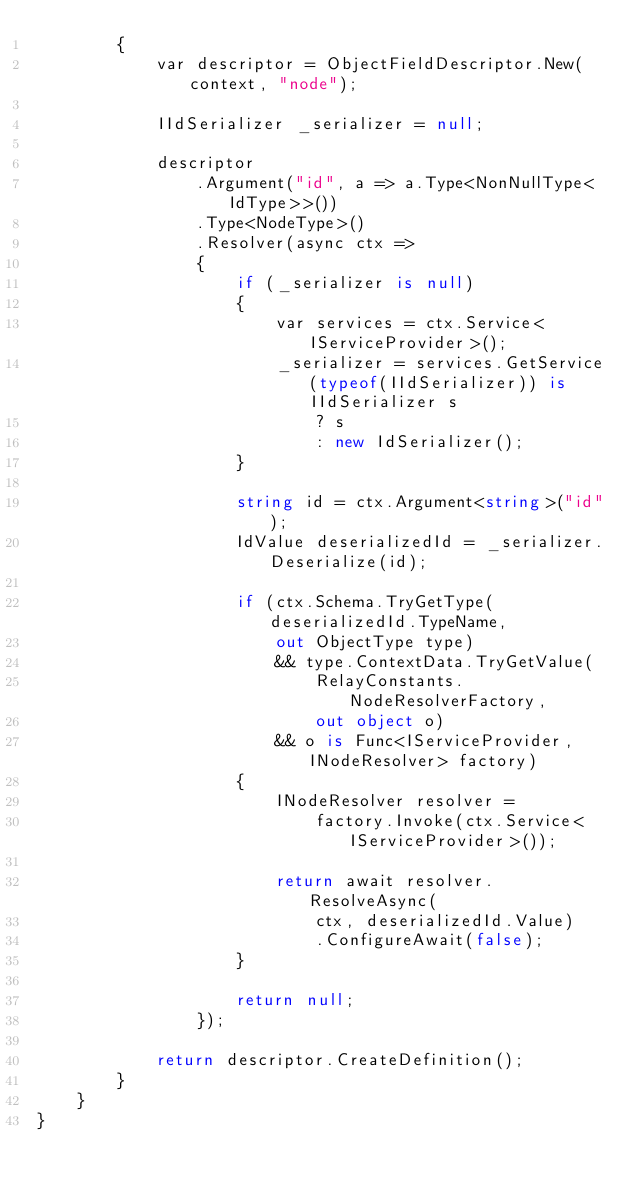Convert code to text. <code><loc_0><loc_0><loc_500><loc_500><_C#_>        {
            var descriptor = ObjectFieldDescriptor.New(context, "node");

            IIdSerializer _serializer = null;

            descriptor
                .Argument("id", a => a.Type<NonNullType<IdType>>())
                .Type<NodeType>()
                .Resolver(async ctx =>
                {
                    if (_serializer is null)
                    {
                        var services = ctx.Service<IServiceProvider>();
                        _serializer = services.GetService(typeof(IIdSerializer)) is IIdSerializer s
                            ? s
                            : new IdSerializer();
                    }

                    string id = ctx.Argument<string>("id");
                    IdValue deserializedId = _serializer.Deserialize(id);

                    if (ctx.Schema.TryGetType(deserializedId.TypeName,
                        out ObjectType type)
                        && type.ContextData.TryGetValue(
                            RelayConstants.NodeResolverFactory,
                            out object o)
                        && o is Func<IServiceProvider, INodeResolver> factory)
                    {
                        INodeResolver resolver =
                            factory.Invoke(ctx.Service<IServiceProvider>());

                        return await resolver.ResolveAsync(
                            ctx, deserializedId.Value)
                            .ConfigureAwait(false);
                    }

                    return null;
                });

            return descriptor.CreateDefinition();
        }
    }
}
</code> 